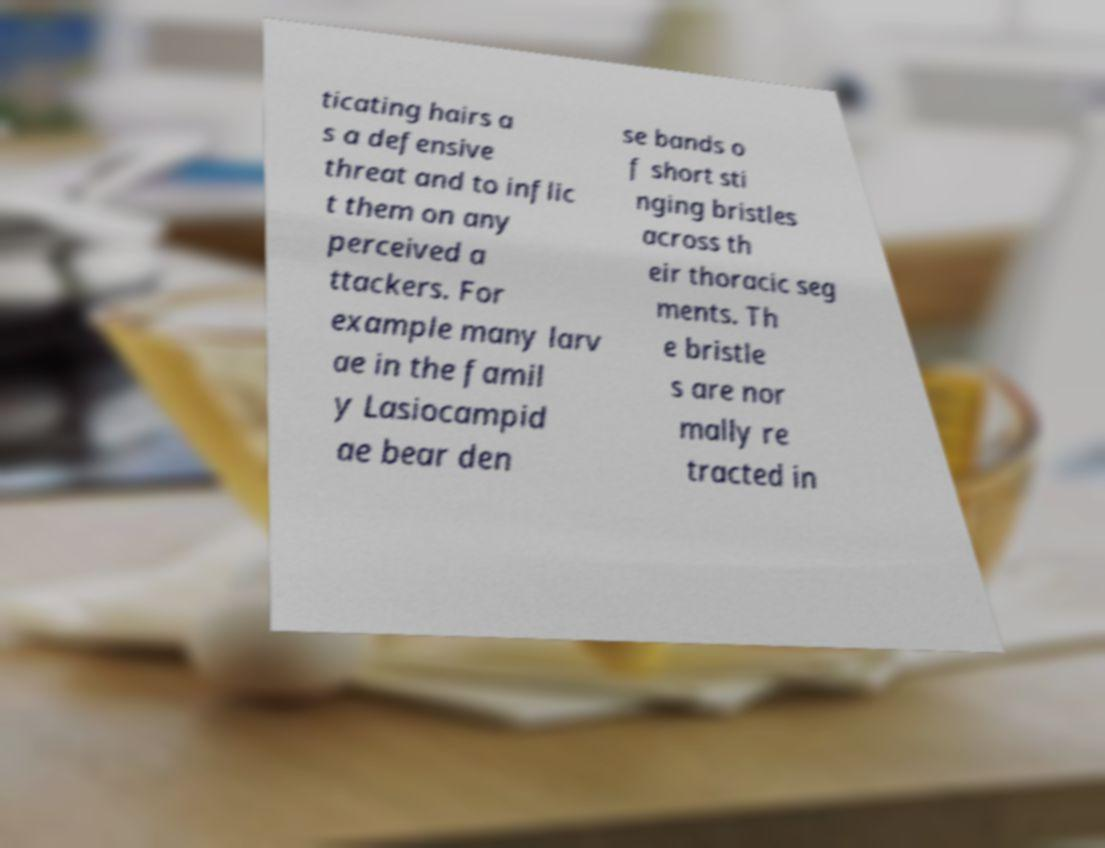What messages or text are displayed in this image? I need them in a readable, typed format. ticating hairs a s a defensive threat and to inflic t them on any perceived a ttackers. For example many larv ae in the famil y Lasiocampid ae bear den se bands o f short sti nging bristles across th eir thoracic seg ments. Th e bristle s are nor mally re tracted in 